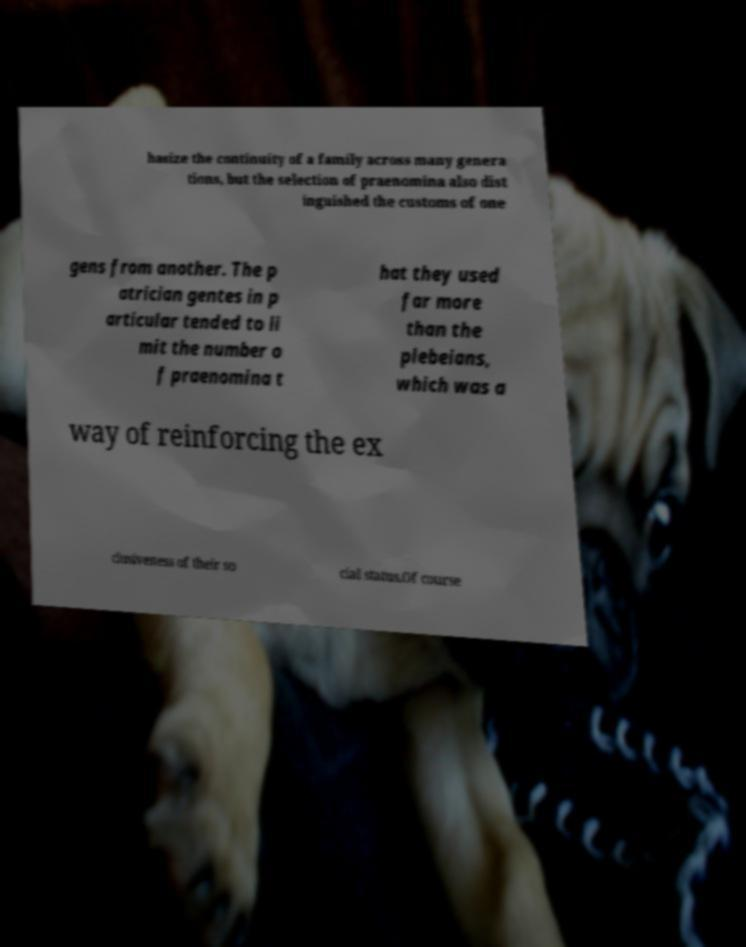What messages or text are displayed in this image? I need them in a readable, typed format. hasize the continuity of a family across many genera tions, but the selection of praenomina also dist inguished the customs of one gens from another. The p atrician gentes in p articular tended to li mit the number o f praenomina t hat they used far more than the plebeians, which was a way of reinforcing the ex clusiveness of their so cial status.Of course 